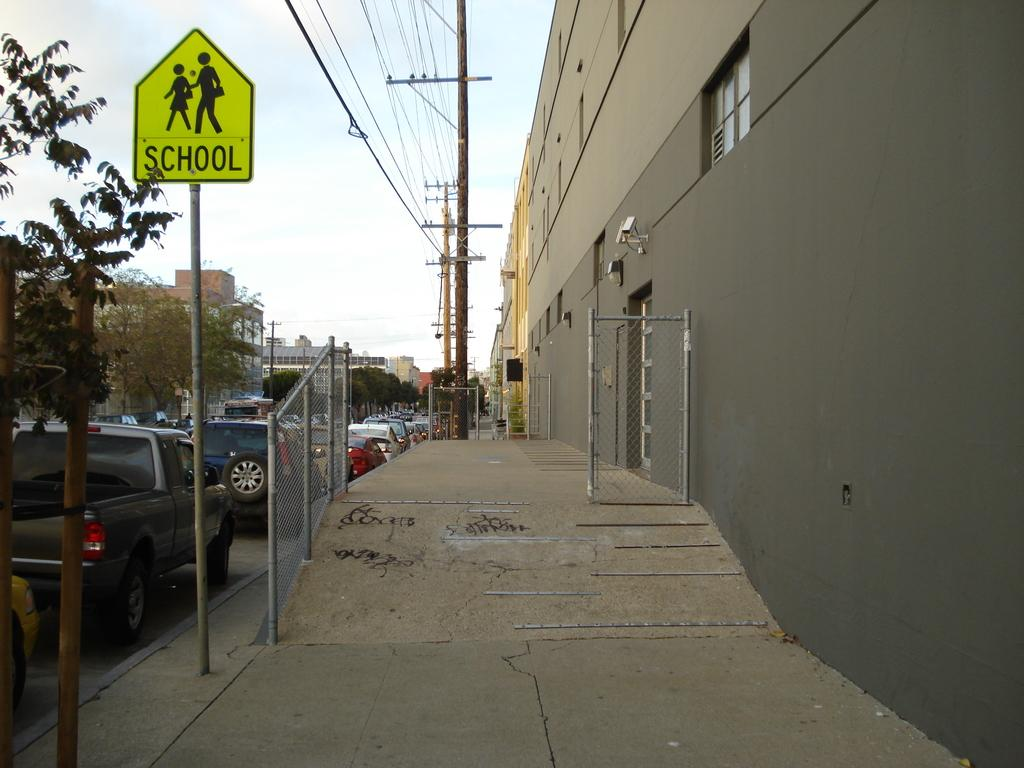Provide a one-sentence caption for the provided image. A bright yellow sign with text of School is mounted on a pole. 